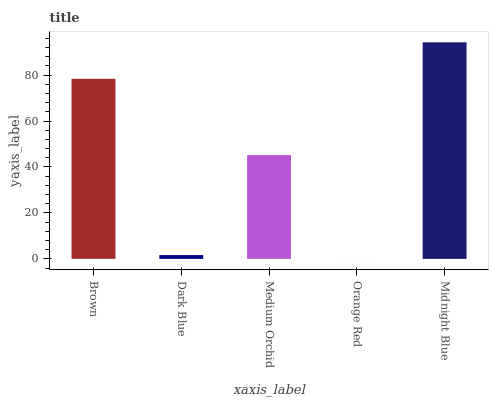Is Orange Red the minimum?
Answer yes or no. Yes. Is Midnight Blue the maximum?
Answer yes or no. Yes. Is Dark Blue the minimum?
Answer yes or no. No. Is Dark Blue the maximum?
Answer yes or no. No. Is Brown greater than Dark Blue?
Answer yes or no. Yes. Is Dark Blue less than Brown?
Answer yes or no. Yes. Is Dark Blue greater than Brown?
Answer yes or no. No. Is Brown less than Dark Blue?
Answer yes or no. No. Is Medium Orchid the high median?
Answer yes or no. Yes. Is Medium Orchid the low median?
Answer yes or no. Yes. Is Dark Blue the high median?
Answer yes or no. No. Is Orange Red the low median?
Answer yes or no. No. 